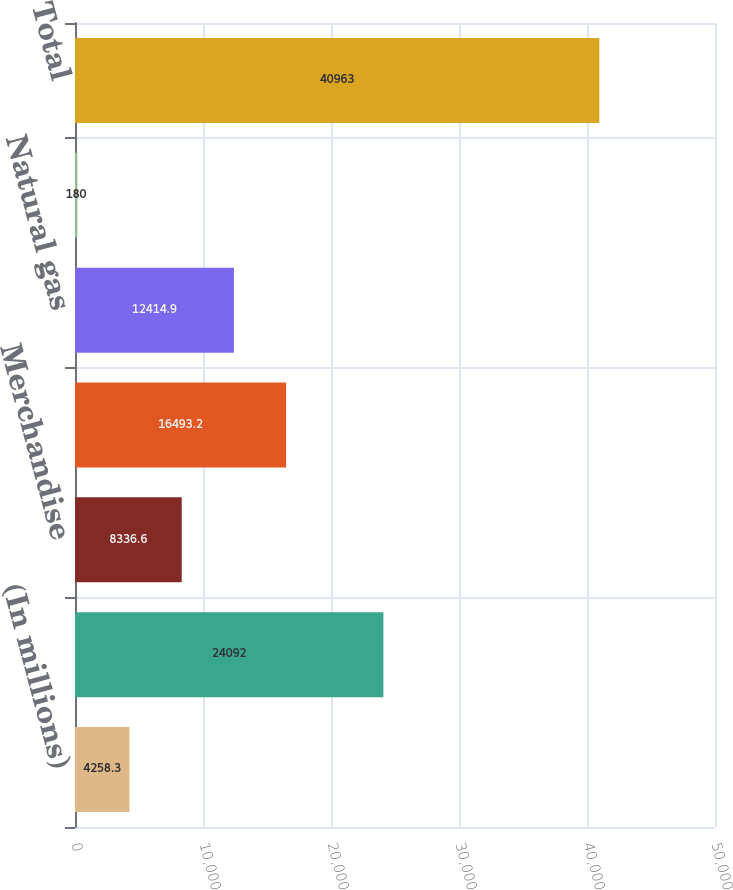Convert chart. <chart><loc_0><loc_0><loc_500><loc_500><bar_chart><fcel>(In millions)<fcel>Refined products<fcel>Merchandise<fcel>Liquid hydrocarbons<fcel>Natural gas<fcel>Transportation and other<fcel>Total<nl><fcel>4258.3<fcel>24092<fcel>8336.6<fcel>16493.2<fcel>12414.9<fcel>180<fcel>40963<nl></chart> 